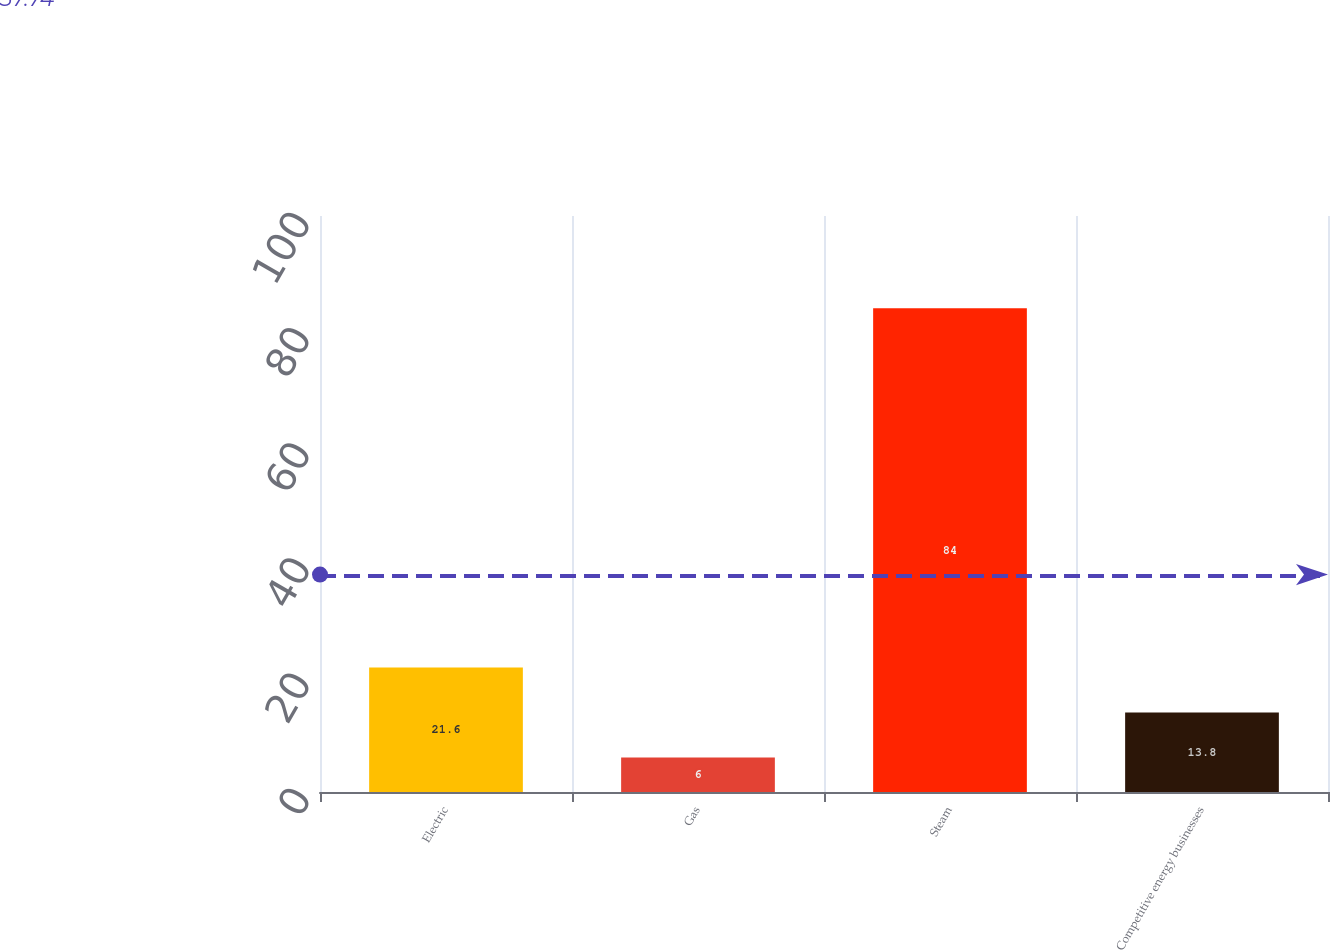<chart> <loc_0><loc_0><loc_500><loc_500><bar_chart><fcel>Electric<fcel>Gas<fcel>Steam<fcel>Competitive energy businesses<nl><fcel>21.6<fcel>6<fcel>84<fcel>13.8<nl></chart> 